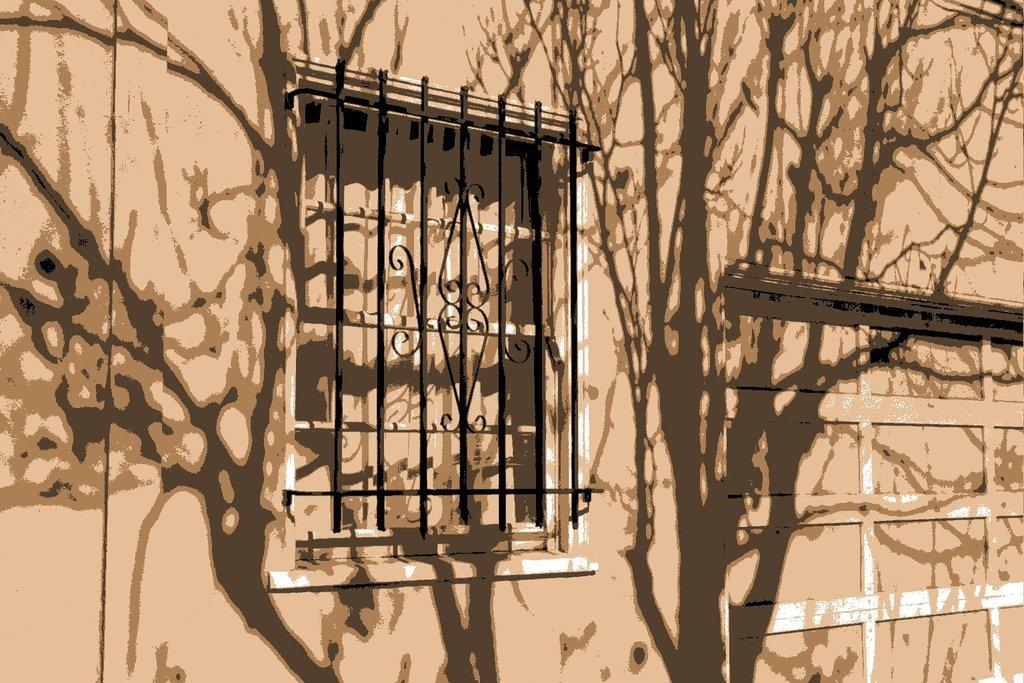What type of structure is depicted in the edited picture? The image contains an edited picture of a building. What are some features of the building? The building has windows, a metal fence, and a door. How does the building aid in the digestion process? The building does not aid in the digestion process; it is an inanimate structure. 